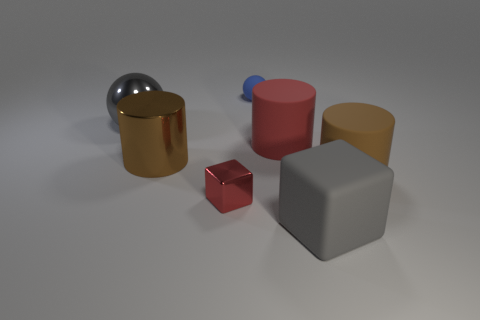Subtract all large matte cylinders. How many cylinders are left? 1 Subtract 2 cylinders. How many cylinders are left? 1 Add 1 brown cylinders. How many objects exist? 8 Subtract all red cylinders. How many cylinders are left? 2 Subtract all cubes. How many objects are left? 5 Subtract all big gray metal balls. Subtract all blue things. How many objects are left? 5 Add 6 small blue rubber things. How many small blue rubber things are left? 7 Add 1 cyan matte cubes. How many cyan matte cubes exist? 1 Subtract 2 brown cylinders. How many objects are left? 5 Subtract all purple cubes. Subtract all blue balls. How many cubes are left? 2 